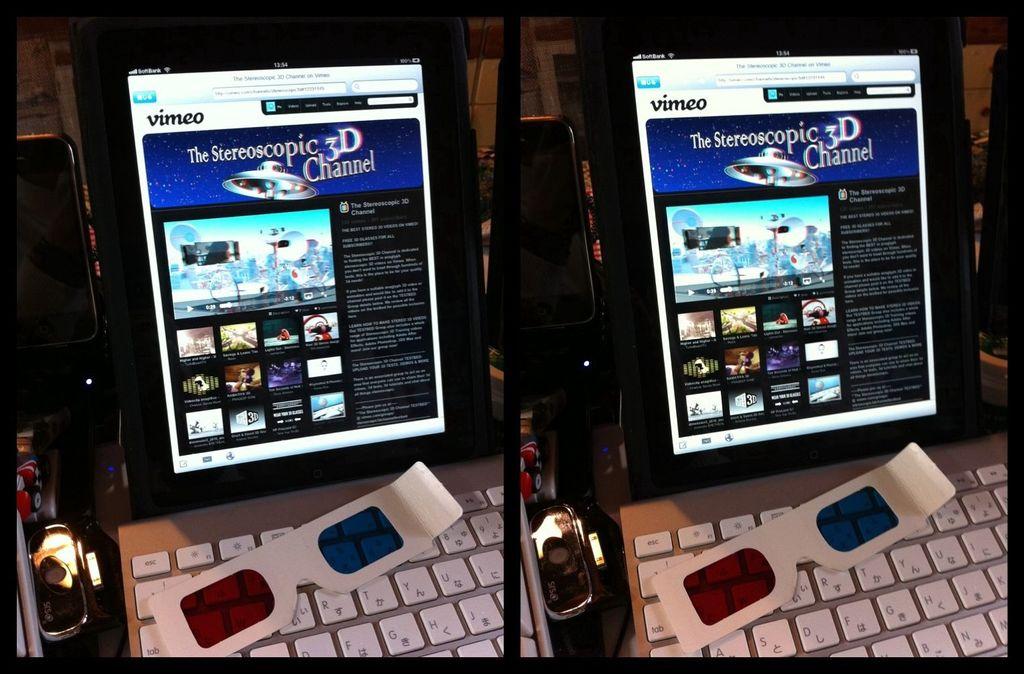What is the name of the channel shown?
Provide a succinct answer. The stereoscopic 3d channel. 